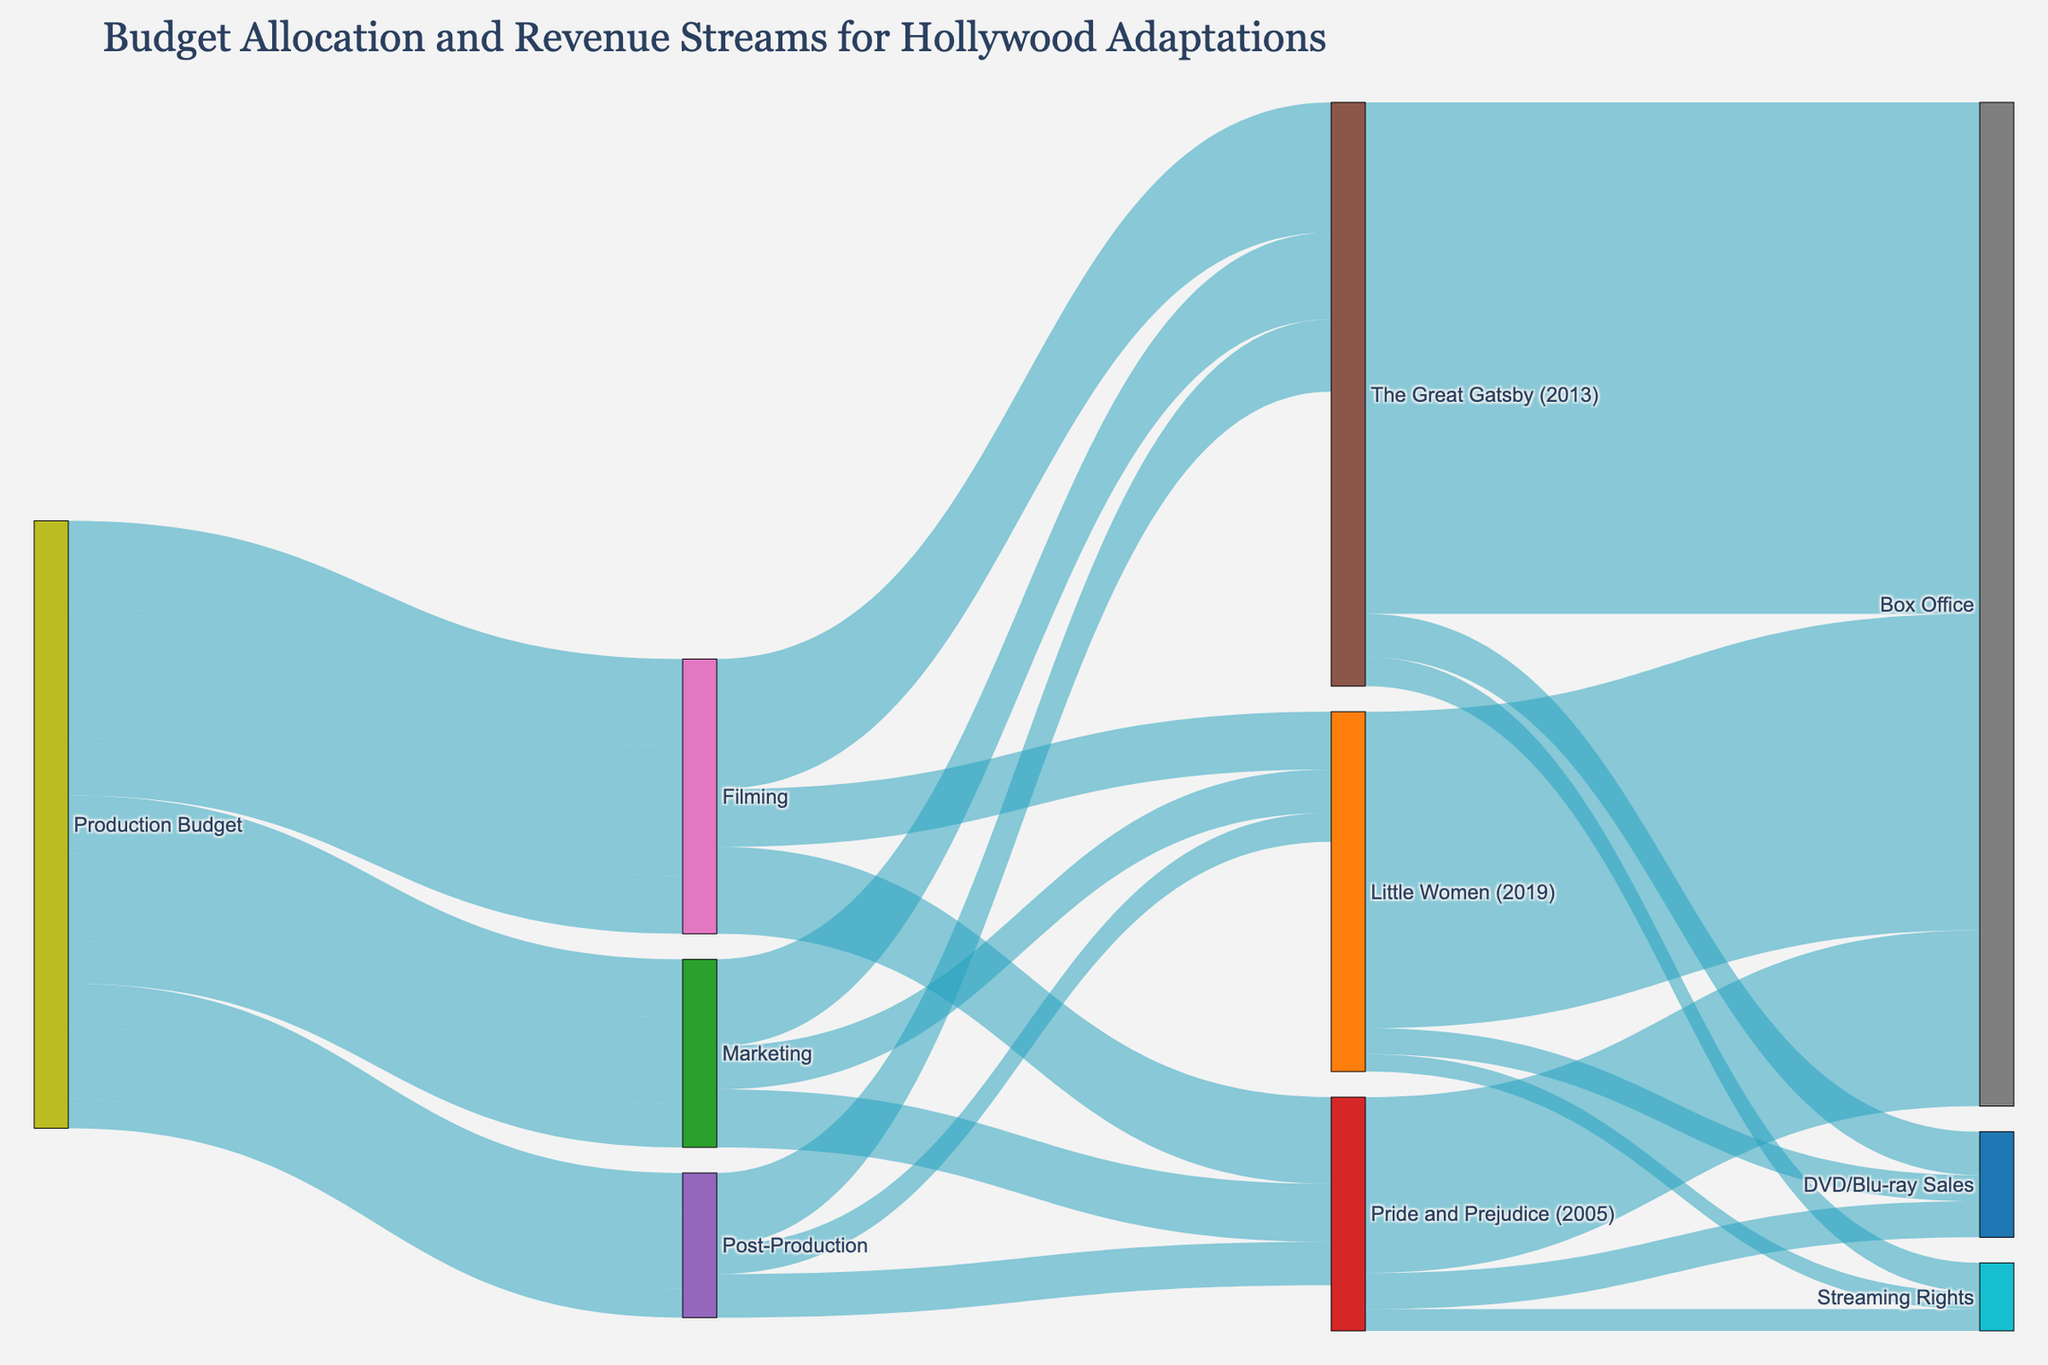Which movie adaptation had the highest production budget allocation for filming? Look at the segment originating from "Production Budget" and going to "Filming" for each movie. The greatest value among them is "The Great Gatsby (2013)" with $90,000,000.
Answer: The Great Gatsby (2013) What is the total revenue generated from box office sales for all three movies? Sum the values for "Box Office" from "Pride and Prejudice (2005)", "The Great Gatsby (2013)", and "Little Women (2019)": 121,617,794 + 353,641,895 + 218,854,181 = 694,113,870.
Answer: 694,113,870 How much more did "Pride and Prejudice (2005)" make from DVD/Blu-ray sales compared to streaming rights? Subtract the value of "Streaming Rights" from "DVD/Blu-ray Sales" for "Pride and Prejudice (2005)": 25,000,000 - 15,000,000 = 10,000,000.
Answer: 10,000,000 Which movie adaptation had the lowest marketing budget? Look at the value of the segment originating from "Production Budget" and going to "Marketing" for each movie. The lowest value among them is "Little Women (2019)" with $30,000,000.
Answer: Little Women (2019) What percentage of the total revenue for "The Great Gatsby (2013)" came from streaming rights? Calculate the total revenue and find the percentage contributed by "Streaming Rights". Total revenue = 353,641,895 + 30,000,000 + 20,000,000 = 403,641,895. Percentage = (20,000,000 / 403,641,895) × 100 ≈ 4.95%.
Answer: ~4.95% Compare the total post-production budgets for all three movies. Which movie had the highest post-production budget? Look at the segments originating from "Production Budget" and going to "Post-Production" for each movie. The highest value among them is "The Great Gatsby (2013)" with $50,000,000.
Answer: The Great Gatsby (2013) For "Little Women (2019)", what is the ratio of the marketing budget to the filming budget? Divide the marketing budget by the filming budget for "Little Women (2019)": 30,000,000 / 40,000,000 = 0.75.
Answer: 0.75 Considering all revenue streams, which movie adaptation was the most profitable? Calculate total revenue for each movie and compare. "Pride and Prejudice (2005)": 121,617,794 + 25,000,000 + 15,000,000 = 161,617,794. "The Great Gatsby (2013)": 353,641,895 + 30,000,000 + 20,000,000 = 403,641,895. "Little Women (2019)": 218,854,181 + 18,000,000 + 12,000,000 = 248,854,181. The greatest value is for "The Great Gatsby (2013)".
Answer: The Great Gatsby (2013) Which of the three movies had the smallest discrepancy between its production budget and its total revenue? Calculate the difference between production budget and total revenue for each movie. "Pride and Prejudice (2005)": (60,000,000 + 40,000,000 + 30,000,000) - (121,617,794 + 25,000,000 + 15,000,000) = 130,000,000 - 161,617,794 = -31,617,794. "The Great Gatsby (2013)": (90,000,000 + 60,000,000 + 50,000,000) - (353,641,895 + 30,000,000 + 20,000,000) = 200,000,000 - 403,641,895 = -203,641,895. "Little Women (2019)": (40,000,000 + 30,000,000 + 20,000,000) - (218,854,181 + 18,000,000 + 12,000,000) = 90,000,000 - 248,854,181 = -158,854,181. The smallest discrepancy is for "Pride and Prejudice (2005)" with -31,617,794.
Answer: Pride and Prejudice (2005) What's the average budget spent on post-production for the three films? Add the post-production budgets for all three movies and divide by three: (30,000,000 + 50,000,000 + 20,000,000) / 3 = 100,000,000 / 3 ≈ 33,333,333.
Answer: 33,333,333 